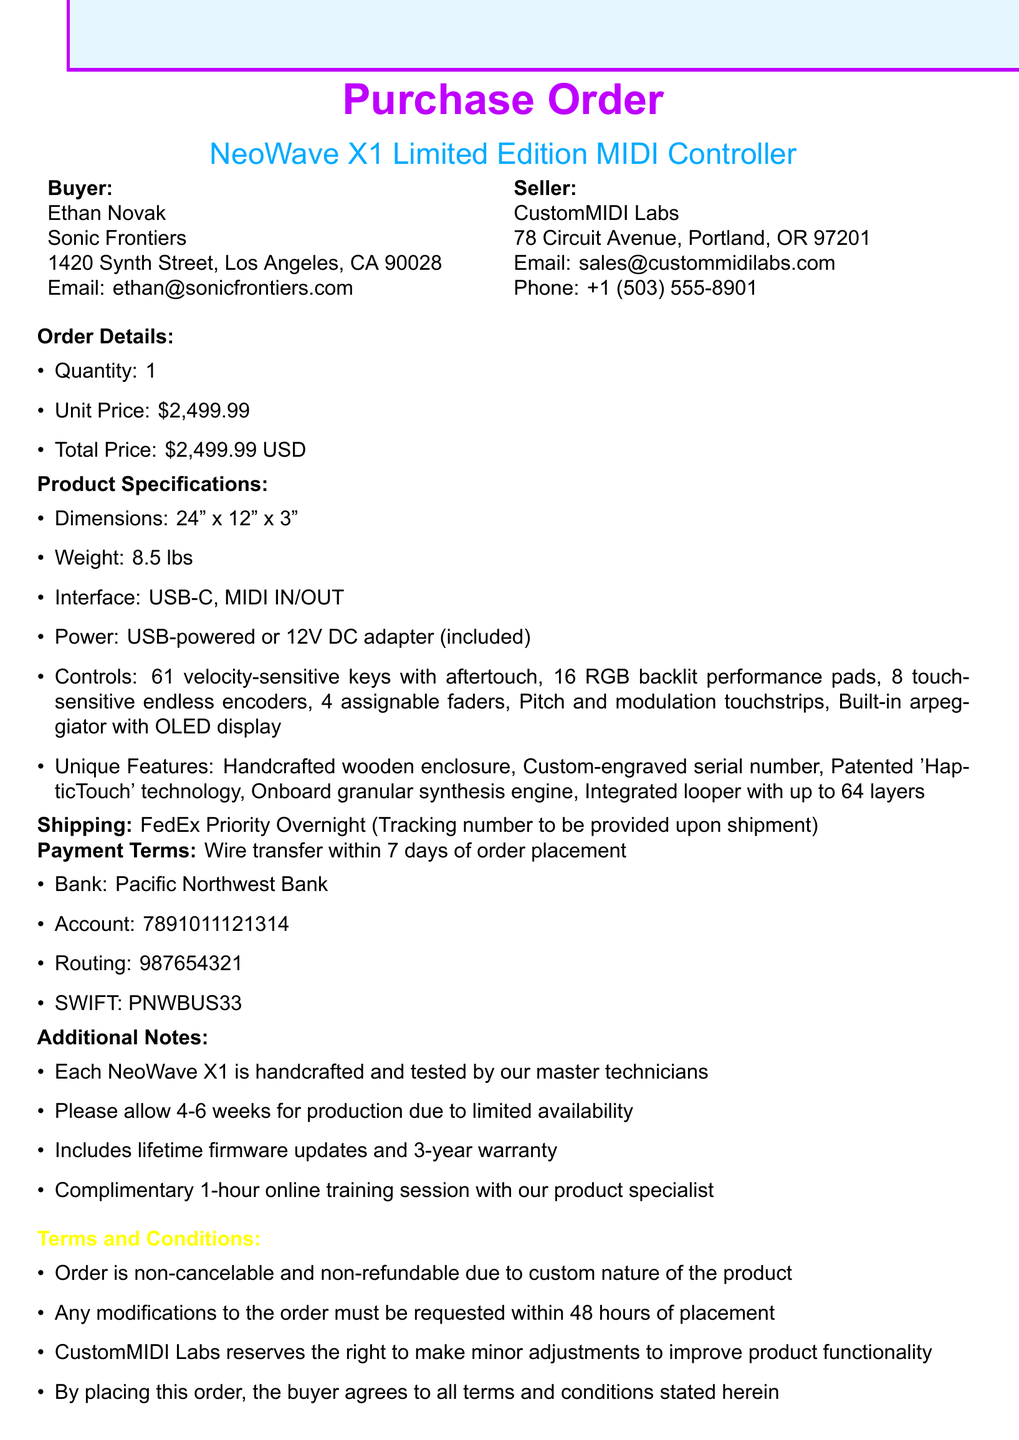What is the buyer's name? The buyer's name is stated explicitly in the document as Ethan Novak.
Answer: Ethan Novak What is the total price of the order? The total price is listed in the order details section as $2,499.99.
Answer: $2,499.99 What unique feature is included in the NeoWave X1? One of the unique features mentioned is the patented 'HapticTouch' technology for enhanced expression.
Answer: Patented 'HapticTouch' technology What is the shipping method for this purchase? The shipping method specified in the document is FedEx Priority Overnight.
Answer: FedEx Priority Overnight What payment method is accepted for the order? The payment method detailed in the document is wire transfer.
Answer: Wire transfer How many velocity-sensitive keys does the controller have? The document states that the controller has 61 velocity-sensitive keys.
Answer: 61 What is the estimated delivery time after production? The estimated delivery time mentioned is within 3 business days after production.
Answer: Within 3 business days What is the warranty period included with the NeoWave X1? The warranty period stated in the additional notes is for 3 years.
Answer: 3 years What must the buyer do to modify the order? The buyer must request any modifications within 48 hours of placement as stated in the terms and conditions.
Answer: Within 48 hours of placement 